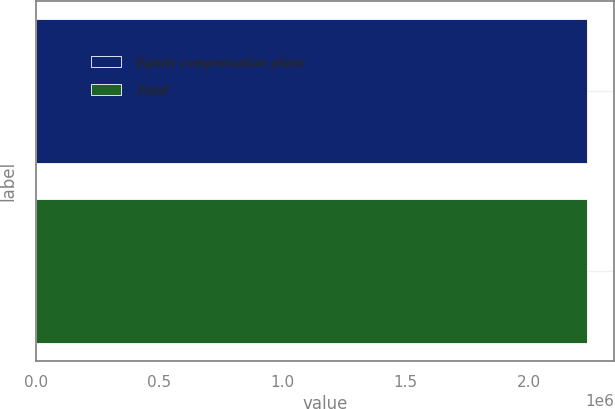Convert chart to OTSL. <chart><loc_0><loc_0><loc_500><loc_500><bar_chart><fcel>Equity compensation plans<fcel>Total<nl><fcel>2.23472e+06<fcel>2.23472e+06<nl></chart> 